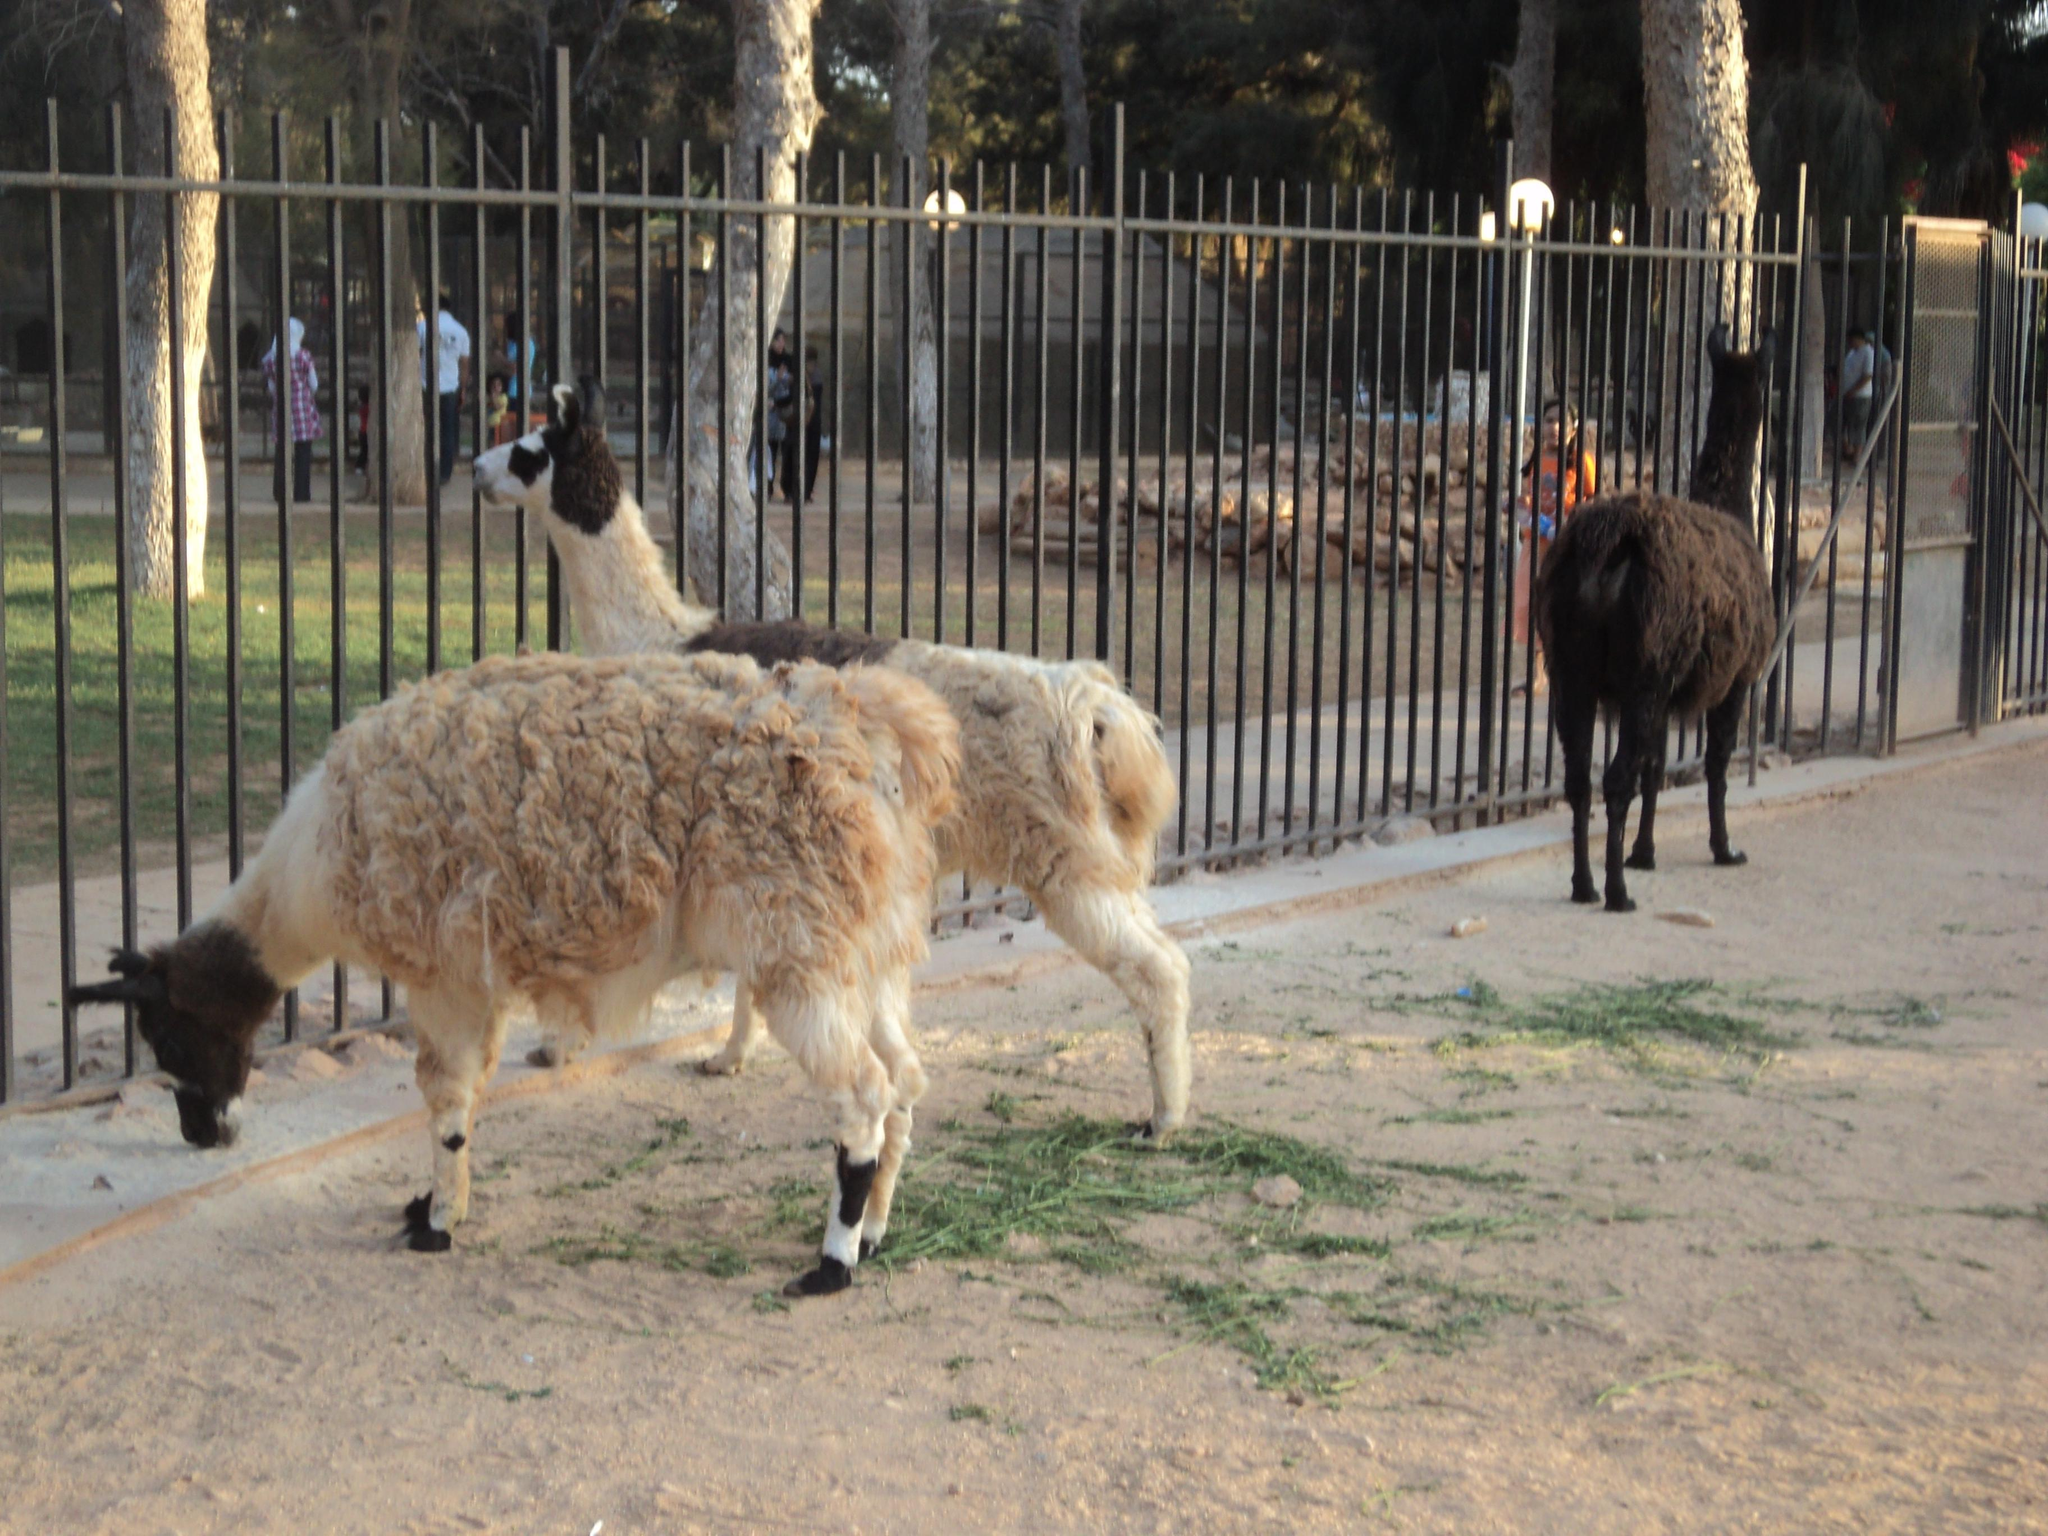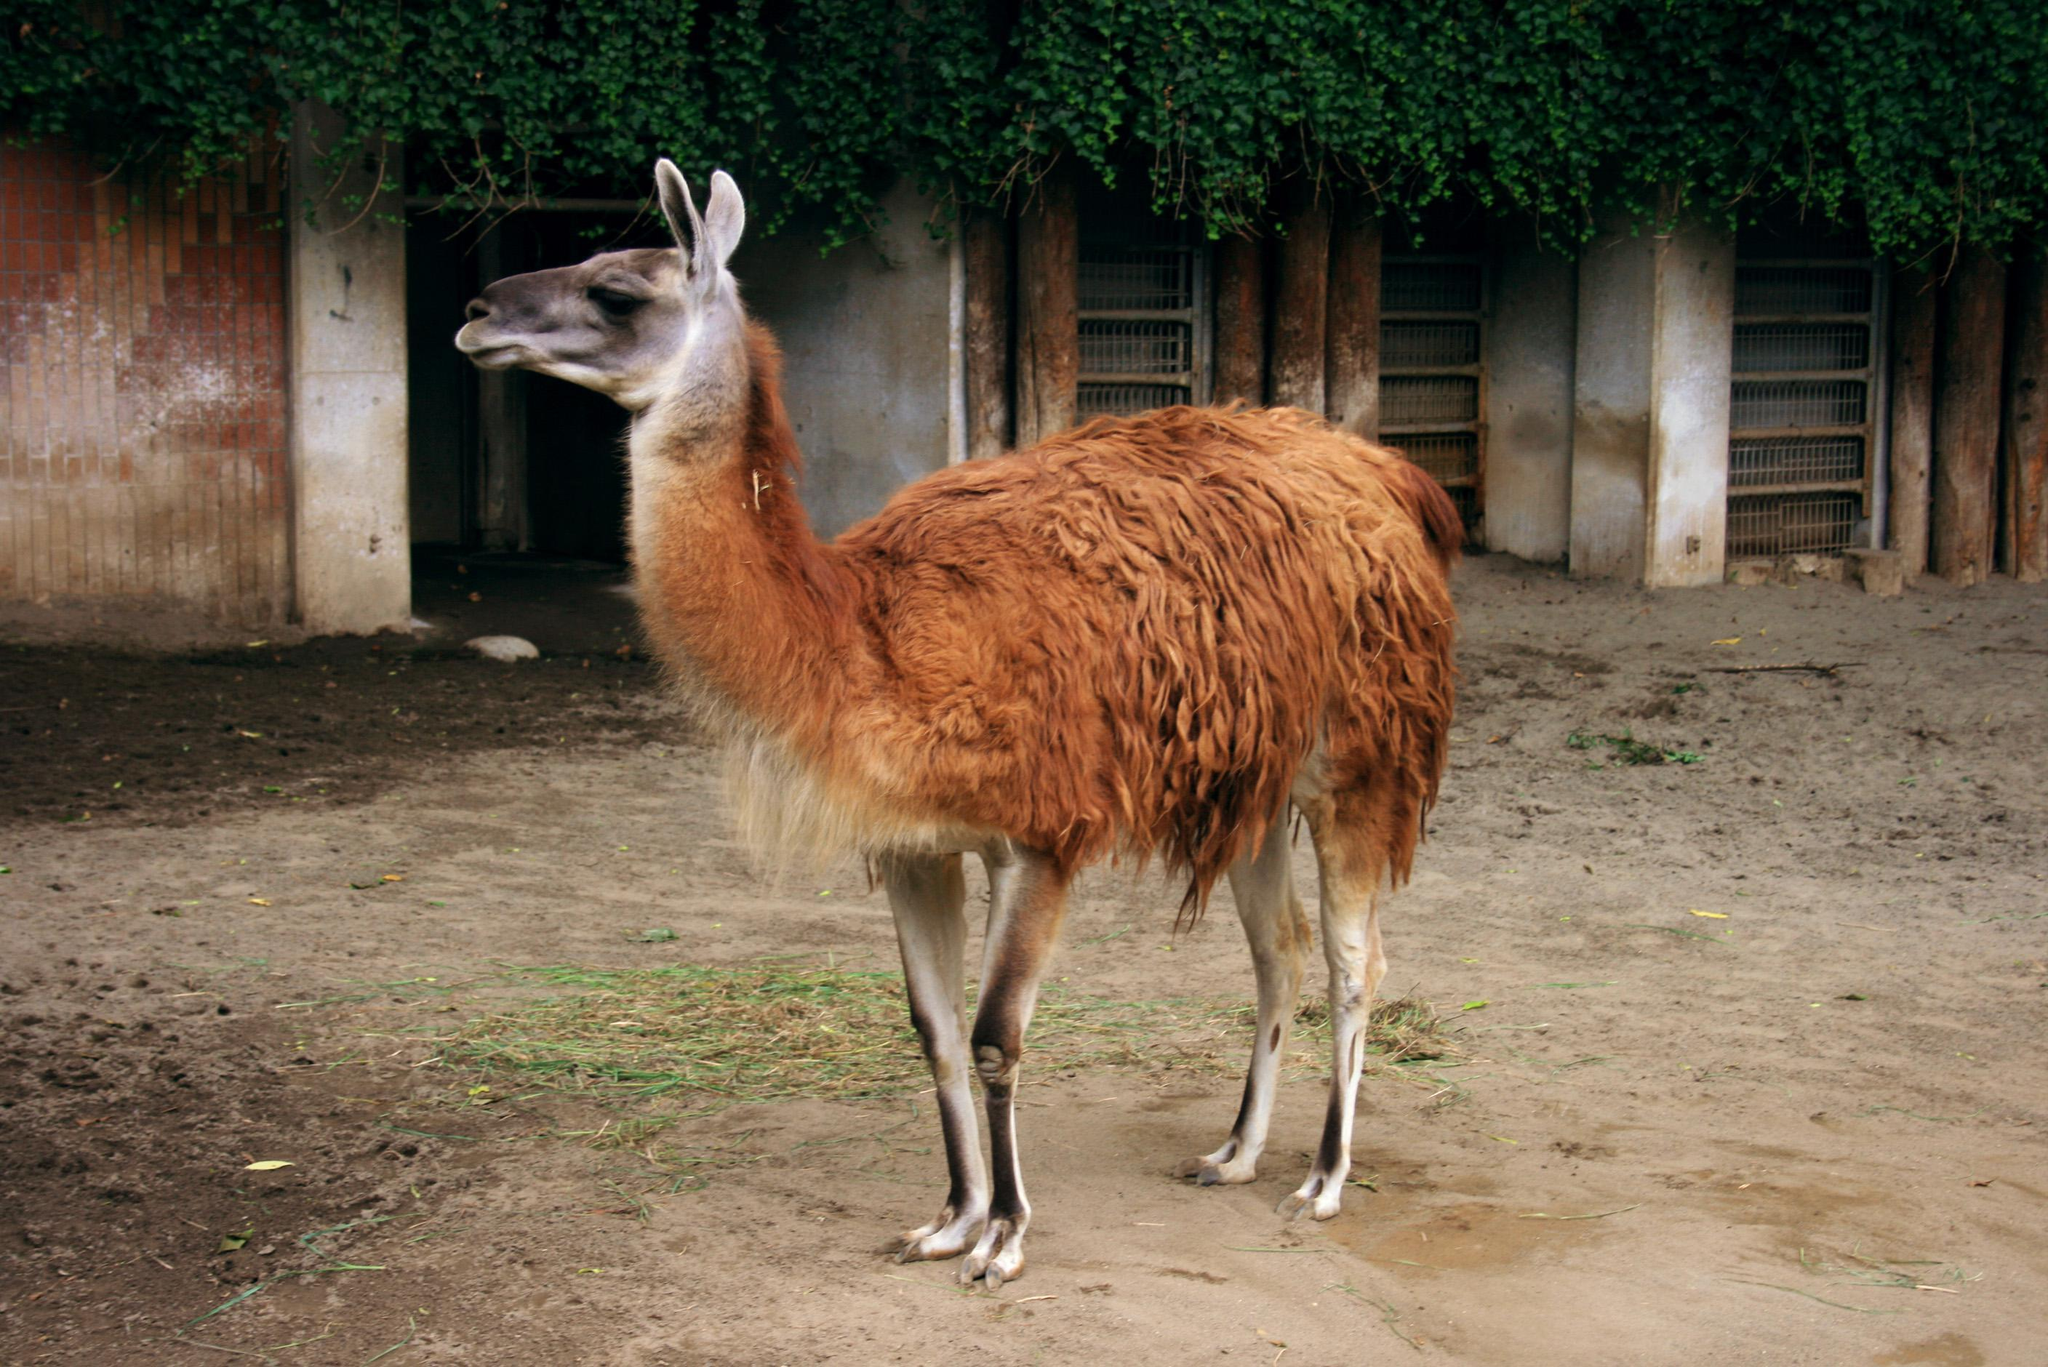The first image is the image on the left, the second image is the image on the right. Analyze the images presented: Is the assertion "There are at most four llamas in the image pair." valid? Answer yes or no. Yes. The first image is the image on the left, the second image is the image on the right. Given the left and right images, does the statement "All llama are standing with upright heads, and all llamas have their bodies turned rightward." hold true? Answer yes or no. No. 